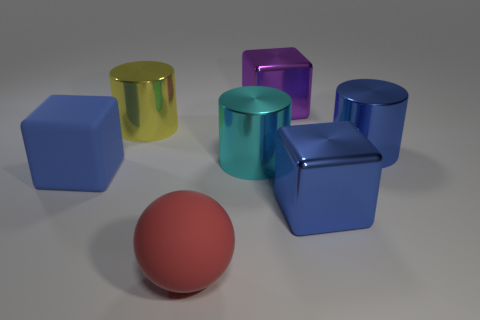There is a block left of the large sphere; is its color the same as the matte ball?
Give a very brief answer. No. What is the size of the blue metallic block?
Your answer should be compact. Large. There is a red sphere that is the same size as the cyan object; what is it made of?
Ensure brevity in your answer.  Rubber. The block to the right of the purple shiny thing is what color?
Give a very brief answer. Blue. What number of cubes are there?
Offer a terse response. 3. Are there any metallic things that are in front of the cylinder in front of the metallic cylinder to the right of the big blue metallic cube?
Provide a short and direct response. Yes. The yellow shiny object that is the same size as the rubber cube is what shape?
Your answer should be very brief. Cylinder. What number of other things are the same color as the large matte cube?
Offer a terse response. 2. What is the purple block made of?
Provide a short and direct response. Metal. How many other objects are there of the same material as the cyan cylinder?
Provide a short and direct response. 4. 